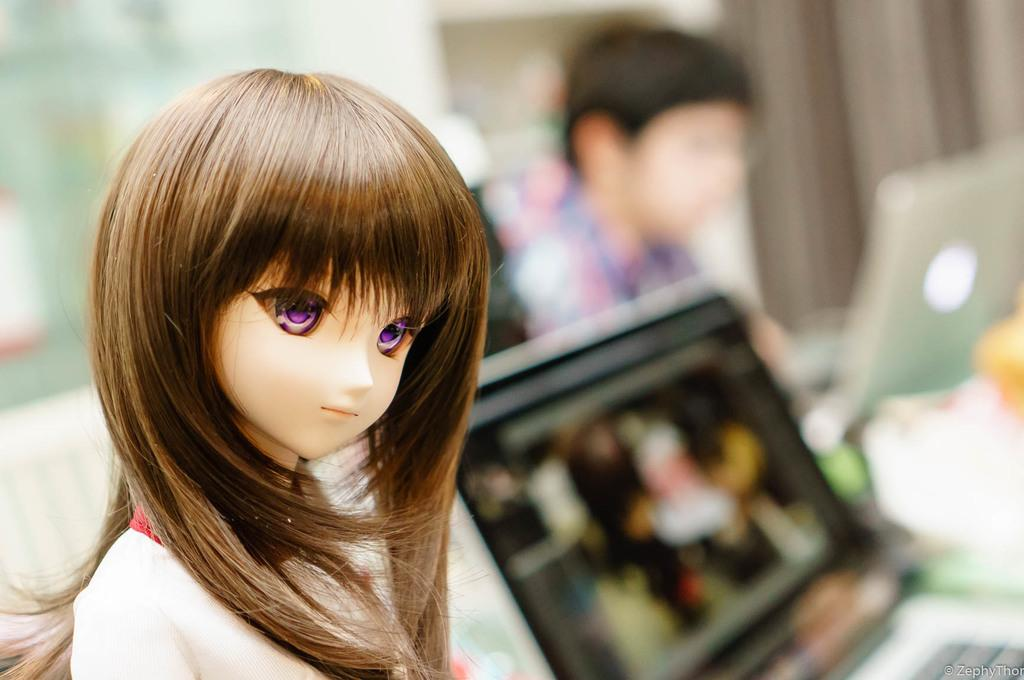What is the main subject in the image? There is a doll in the image. What is the person in the background doing? The person is working on a laptop in the background. Are there any other laptops visible in the image? Yes, there is another laptop beside the person. How would you describe the background of the image? The background is blurred. What type of needle is being used by the person in the image? There is no needle present in the image; the person is working on a laptop. 